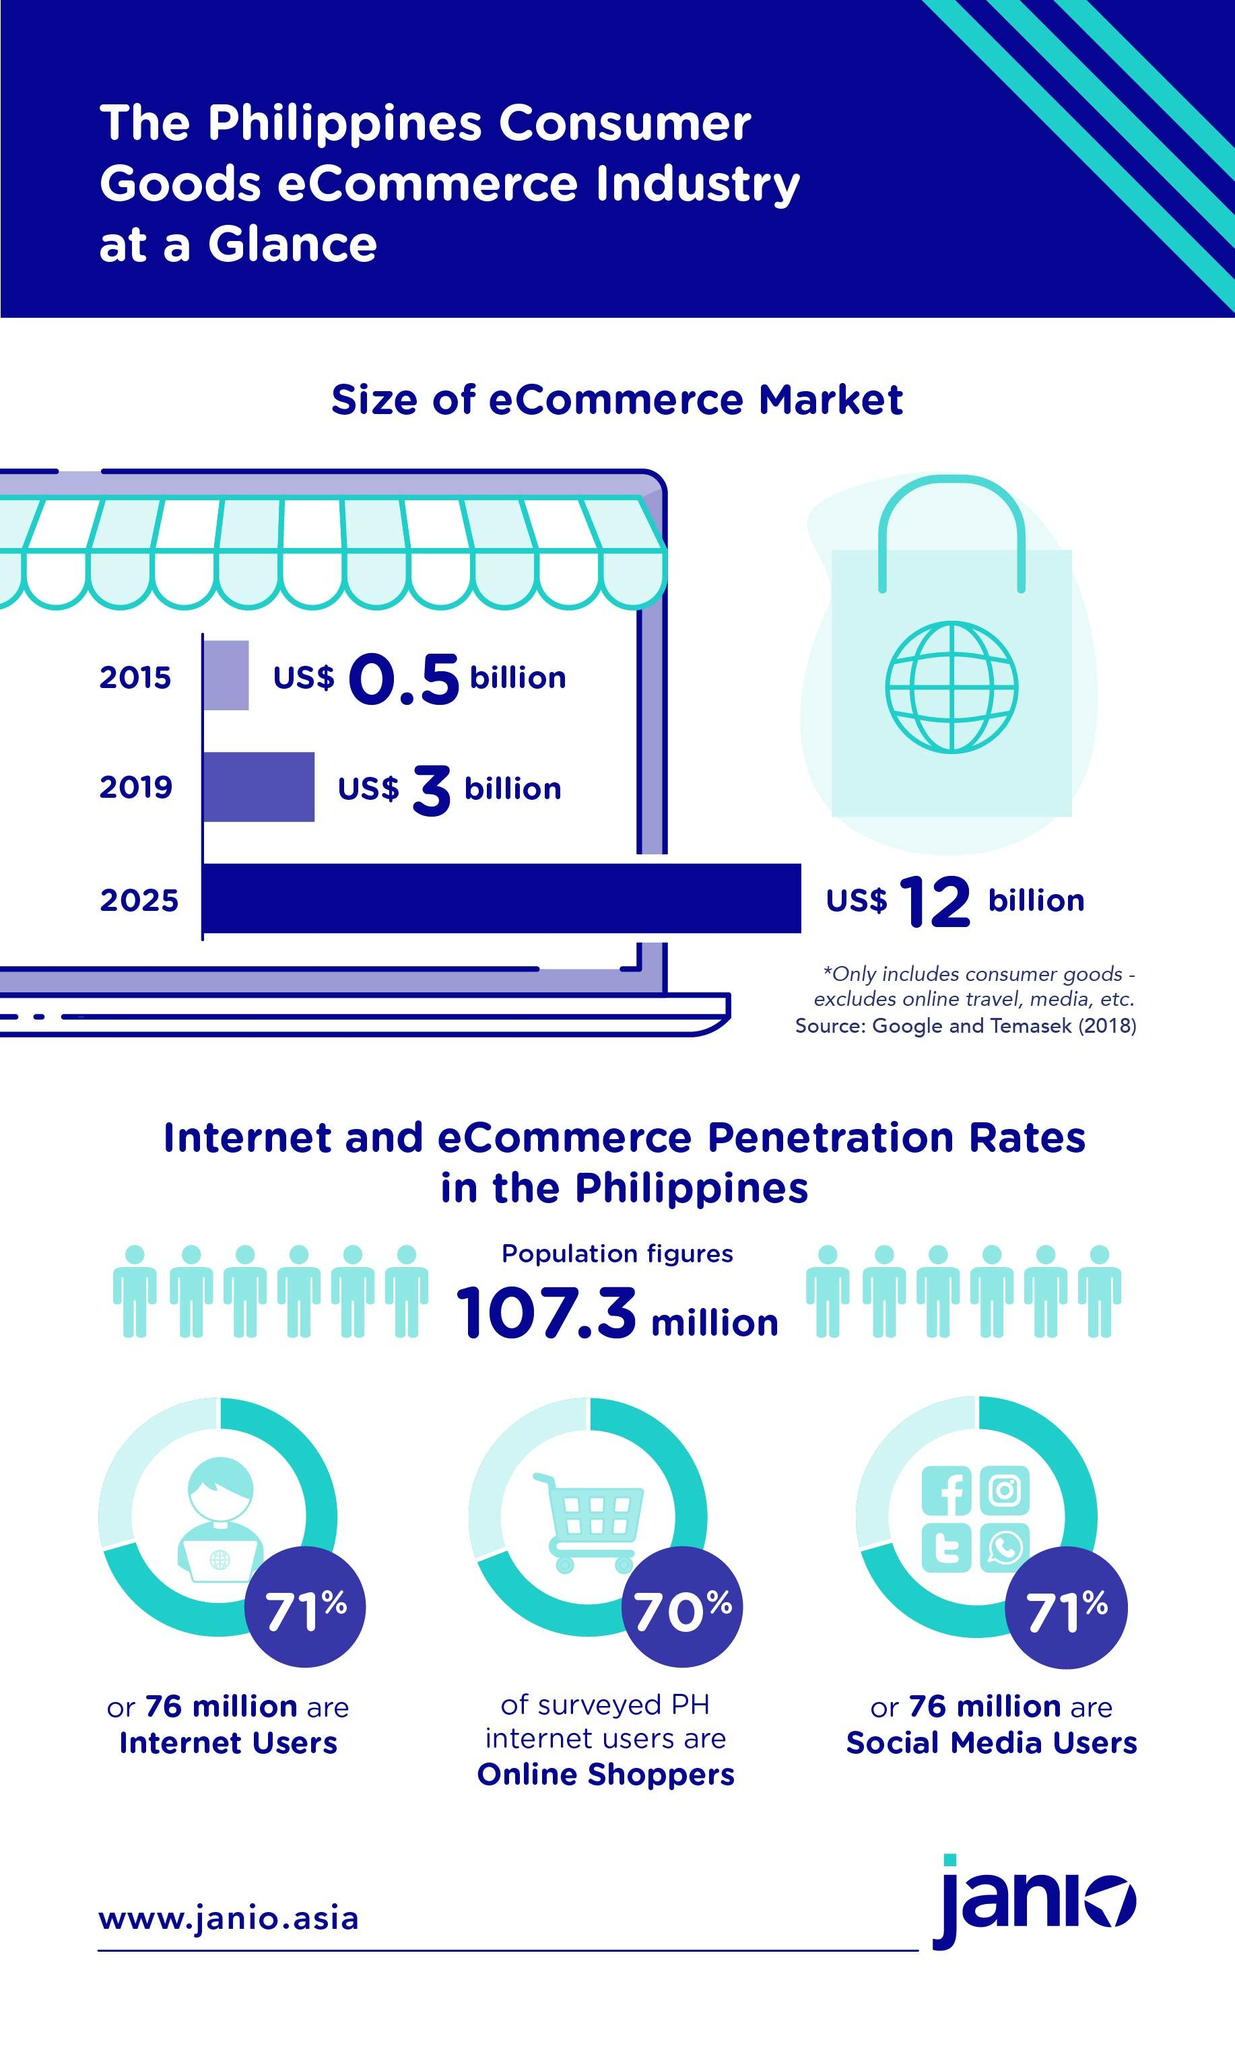Specify some key components in this picture. There are approximately 76 million social media users in the Philippines. Nearly three-quarters of the population, or 71%, are social media users. In the population, 71% of the individuals are internet users. According to a survey, approximately 70% of internet users are also online shoppers. 